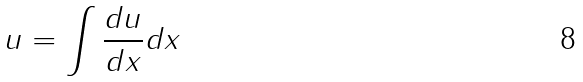Convert formula to latex. <formula><loc_0><loc_0><loc_500><loc_500>u = \int \frac { d u } { d x } d x</formula> 